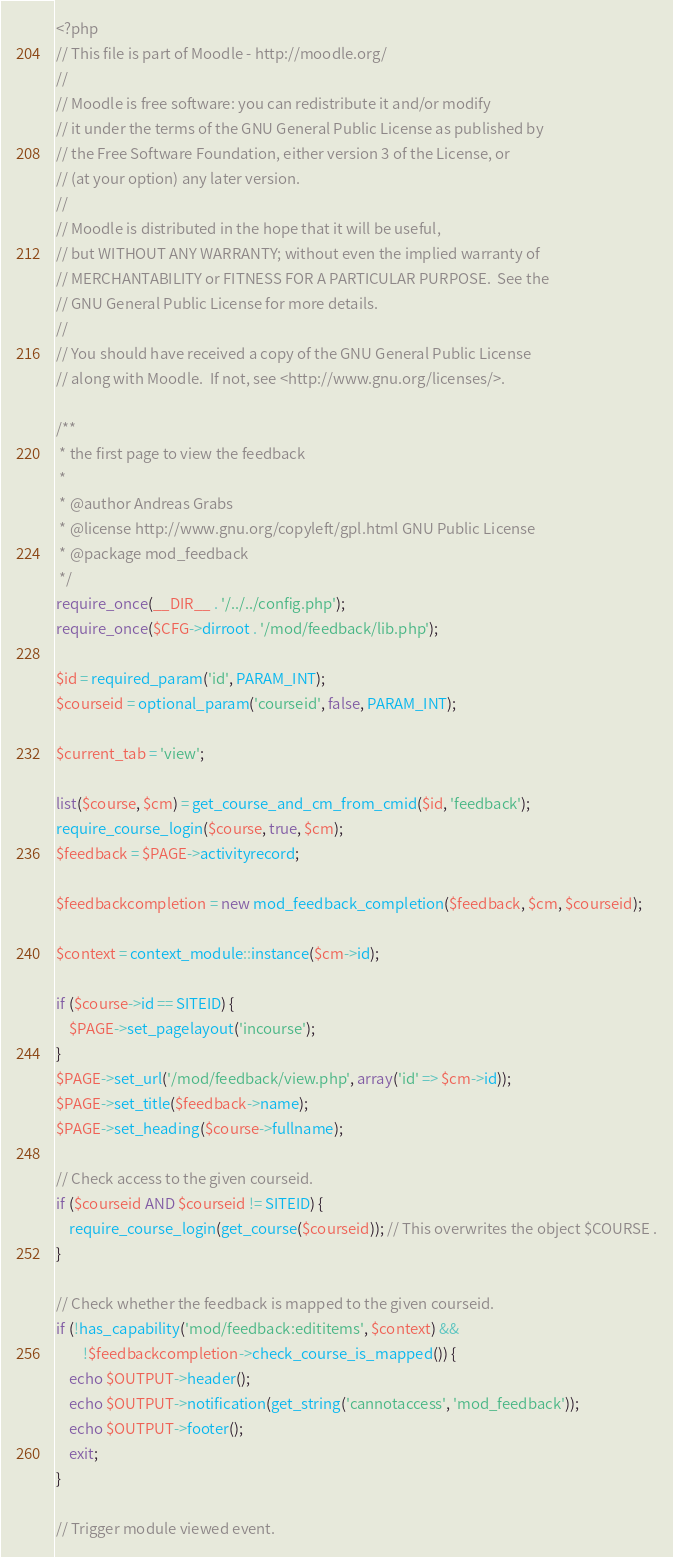<code> <loc_0><loc_0><loc_500><loc_500><_PHP_><?php
// This file is part of Moodle - http://moodle.org/
//
// Moodle is free software: you can redistribute it and/or modify
// it under the terms of the GNU General Public License as published by
// the Free Software Foundation, either version 3 of the License, or
// (at your option) any later version.
//
// Moodle is distributed in the hope that it will be useful,
// but WITHOUT ANY WARRANTY; without even the implied warranty of
// MERCHANTABILITY or FITNESS FOR A PARTICULAR PURPOSE.  See the
// GNU General Public License for more details.
//
// You should have received a copy of the GNU General Public License
// along with Moodle.  If not, see <http://www.gnu.org/licenses/>.

/**
 * the first page to view the feedback
 *
 * @author Andreas Grabs
 * @license http://www.gnu.org/copyleft/gpl.html GNU Public License
 * @package mod_feedback
 */
require_once(__DIR__ . '/../../config.php');
require_once($CFG->dirroot . '/mod/feedback/lib.php');

$id = required_param('id', PARAM_INT);
$courseid = optional_param('courseid', false, PARAM_INT);

$current_tab = 'view';

list($course, $cm) = get_course_and_cm_from_cmid($id, 'feedback');
require_course_login($course, true, $cm);
$feedback = $PAGE->activityrecord;

$feedbackcompletion = new mod_feedback_completion($feedback, $cm, $courseid);

$context = context_module::instance($cm->id);

if ($course->id == SITEID) {
    $PAGE->set_pagelayout('incourse');
}
$PAGE->set_url('/mod/feedback/view.php', array('id' => $cm->id));
$PAGE->set_title($feedback->name);
$PAGE->set_heading($course->fullname);

// Check access to the given courseid.
if ($courseid AND $courseid != SITEID) {
    require_course_login(get_course($courseid)); // This overwrites the object $COURSE .
}

// Check whether the feedback is mapped to the given courseid.
if (!has_capability('mod/feedback:edititems', $context) &&
        !$feedbackcompletion->check_course_is_mapped()) {
    echo $OUTPUT->header();
    echo $OUTPUT->notification(get_string('cannotaccess', 'mod_feedback'));
    echo $OUTPUT->footer();
    exit;
}

// Trigger module viewed event.</code> 